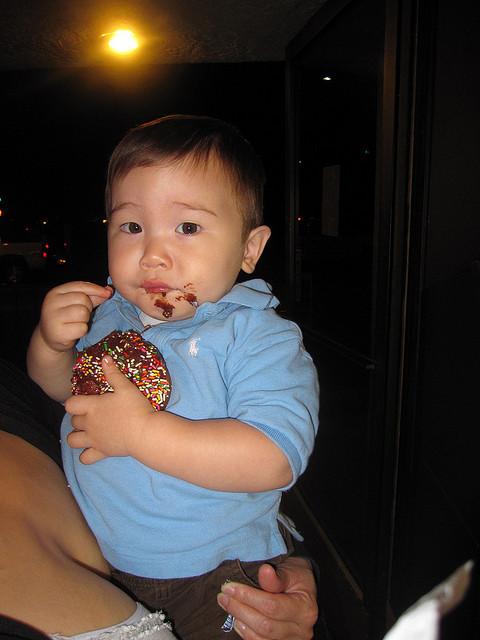What is the baby being fed?
Give a very brief answer. Donut. What is the boy doing?
Concise answer only. Eating. Is this food good for the baby?
Answer briefly. No. What color is the child's shirt?
Be succinct. Blue. Is the baby wearing pajamas?
Write a very short answer. No. What is the kid eating?
Concise answer only. Donut. What is on the boys shirt?
Keep it brief. Donut. What is the kid holding?
Give a very brief answer. Donut. Is the child chewing on a donut or a bagel?
Give a very brief answer. Donut. Is this child eating something considered a health food?
Short answer required. No. Is the child of German descent?
Short answer required. No. Is the baby wearing a shirt?
Answer briefly. Yes. What is on the baby's onesie?
Quick response, please. Donut. Is this child more likely male or female?
Write a very short answer. Male. Do these kids like fruit?
Answer briefly. No. Is the child's shirt a solid color, or striped?
Concise answer only. Solid. 